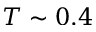<formula> <loc_0><loc_0><loc_500><loc_500>T \sim 0 . 4</formula> 